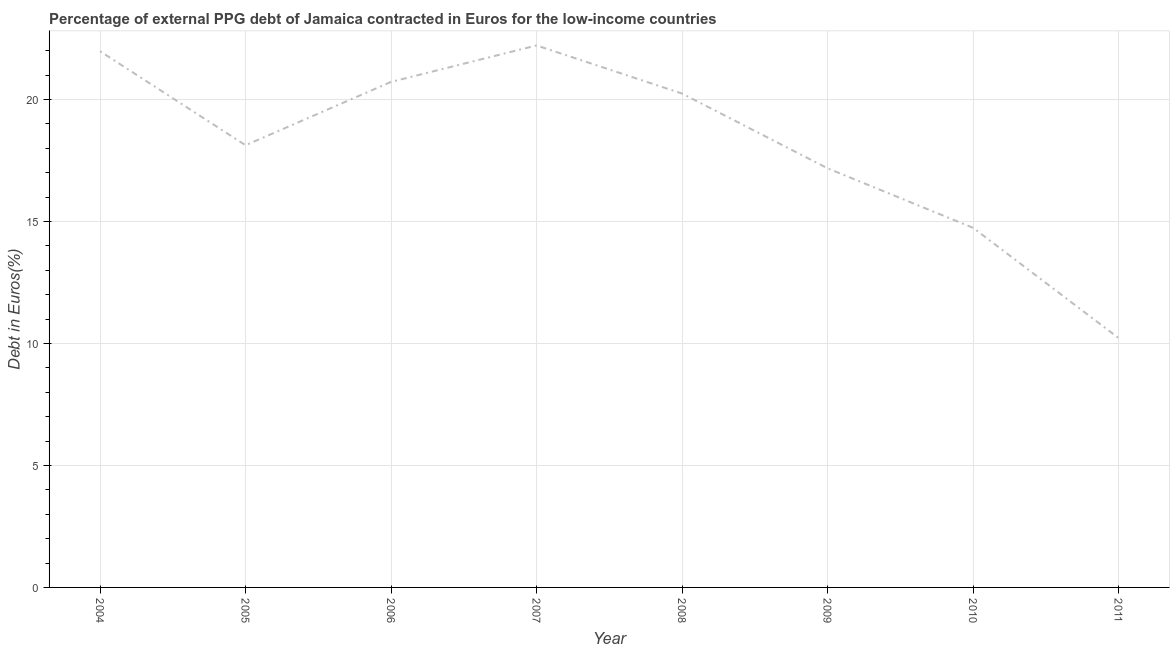What is the currency composition of ppg debt in 2005?
Ensure brevity in your answer.  18.13. Across all years, what is the maximum currency composition of ppg debt?
Offer a very short reply. 22.22. Across all years, what is the minimum currency composition of ppg debt?
Your answer should be very brief. 10.23. What is the sum of the currency composition of ppg debt?
Ensure brevity in your answer.  145.46. What is the difference between the currency composition of ppg debt in 2004 and 2005?
Offer a very short reply. 3.86. What is the average currency composition of ppg debt per year?
Offer a very short reply. 18.18. What is the median currency composition of ppg debt?
Make the answer very short. 19.19. In how many years, is the currency composition of ppg debt greater than 16 %?
Keep it short and to the point. 6. What is the ratio of the currency composition of ppg debt in 2005 to that in 2008?
Offer a terse response. 0.9. Is the currency composition of ppg debt in 2006 less than that in 2007?
Give a very brief answer. Yes. Is the difference between the currency composition of ppg debt in 2008 and 2011 greater than the difference between any two years?
Give a very brief answer. No. What is the difference between the highest and the second highest currency composition of ppg debt?
Give a very brief answer. 0.24. Is the sum of the currency composition of ppg debt in 2004 and 2007 greater than the maximum currency composition of ppg debt across all years?
Give a very brief answer. Yes. What is the difference between the highest and the lowest currency composition of ppg debt?
Make the answer very short. 11.99. Does the currency composition of ppg debt monotonically increase over the years?
Give a very brief answer. No. How many lines are there?
Make the answer very short. 1. Does the graph contain any zero values?
Give a very brief answer. No. What is the title of the graph?
Provide a succinct answer. Percentage of external PPG debt of Jamaica contracted in Euros for the low-income countries. What is the label or title of the X-axis?
Your answer should be compact. Year. What is the label or title of the Y-axis?
Offer a very short reply. Debt in Euros(%). What is the Debt in Euros(%) of 2004?
Your answer should be compact. 21.98. What is the Debt in Euros(%) of 2005?
Ensure brevity in your answer.  18.13. What is the Debt in Euros(%) in 2006?
Your answer should be very brief. 20.73. What is the Debt in Euros(%) in 2007?
Give a very brief answer. 22.22. What is the Debt in Euros(%) of 2008?
Offer a terse response. 20.25. What is the Debt in Euros(%) of 2009?
Ensure brevity in your answer.  17.18. What is the Debt in Euros(%) in 2010?
Give a very brief answer. 14.74. What is the Debt in Euros(%) in 2011?
Offer a very short reply. 10.23. What is the difference between the Debt in Euros(%) in 2004 and 2005?
Keep it short and to the point. 3.86. What is the difference between the Debt in Euros(%) in 2004 and 2006?
Your answer should be compact. 1.26. What is the difference between the Debt in Euros(%) in 2004 and 2007?
Offer a very short reply. -0.24. What is the difference between the Debt in Euros(%) in 2004 and 2008?
Your answer should be compact. 1.74. What is the difference between the Debt in Euros(%) in 2004 and 2009?
Make the answer very short. 4.8. What is the difference between the Debt in Euros(%) in 2004 and 2010?
Keep it short and to the point. 7.24. What is the difference between the Debt in Euros(%) in 2004 and 2011?
Provide a succinct answer. 11.76. What is the difference between the Debt in Euros(%) in 2005 and 2006?
Your answer should be compact. -2.6. What is the difference between the Debt in Euros(%) in 2005 and 2007?
Offer a terse response. -4.09. What is the difference between the Debt in Euros(%) in 2005 and 2008?
Your answer should be very brief. -2.12. What is the difference between the Debt in Euros(%) in 2005 and 2009?
Give a very brief answer. 0.94. What is the difference between the Debt in Euros(%) in 2005 and 2010?
Your answer should be very brief. 3.38. What is the difference between the Debt in Euros(%) in 2005 and 2011?
Your answer should be very brief. 7.9. What is the difference between the Debt in Euros(%) in 2006 and 2007?
Your response must be concise. -1.49. What is the difference between the Debt in Euros(%) in 2006 and 2008?
Keep it short and to the point. 0.48. What is the difference between the Debt in Euros(%) in 2006 and 2009?
Give a very brief answer. 3.54. What is the difference between the Debt in Euros(%) in 2006 and 2010?
Ensure brevity in your answer.  5.98. What is the difference between the Debt in Euros(%) in 2006 and 2011?
Keep it short and to the point. 10.5. What is the difference between the Debt in Euros(%) in 2007 and 2008?
Ensure brevity in your answer.  1.97. What is the difference between the Debt in Euros(%) in 2007 and 2009?
Give a very brief answer. 5.04. What is the difference between the Debt in Euros(%) in 2007 and 2010?
Your answer should be very brief. 7.48. What is the difference between the Debt in Euros(%) in 2007 and 2011?
Your answer should be compact. 11.99. What is the difference between the Debt in Euros(%) in 2008 and 2009?
Make the answer very short. 3.06. What is the difference between the Debt in Euros(%) in 2008 and 2010?
Offer a terse response. 5.5. What is the difference between the Debt in Euros(%) in 2008 and 2011?
Ensure brevity in your answer.  10.02. What is the difference between the Debt in Euros(%) in 2009 and 2010?
Your answer should be compact. 2.44. What is the difference between the Debt in Euros(%) in 2009 and 2011?
Keep it short and to the point. 6.96. What is the difference between the Debt in Euros(%) in 2010 and 2011?
Your response must be concise. 4.52. What is the ratio of the Debt in Euros(%) in 2004 to that in 2005?
Provide a succinct answer. 1.21. What is the ratio of the Debt in Euros(%) in 2004 to that in 2006?
Your answer should be very brief. 1.06. What is the ratio of the Debt in Euros(%) in 2004 to that in 2008?
Your answer should be compact. 1.09. What is the ratio of the Debt in Euros(%) in 2004 to that in 2009?
Provide a short and direct response. 1.28. What is the ratio of the Debt in Euros(%) in 2004 to that in 2010?
Provide a succinct answer. 1.49. What is the ratio of the Debt in Euros(%) in 2004 to that in 2011?
Your answer should be compact. 2.15. What is the ratio of the Debt in Euros(%) in 2005 to that in 2007?
Your answer should be compact. 0.82. What is the ratio of the Debt in Euros(%) in 2005 to that in 2008?
Keep it short and to the point. 0.9. What is the ratio of the Debt in Euros(%) in 2005 to that in 2009?
Keep it short and to the point. 1.05. What is the ratio of the Debt in Euros(%) in 2005 to that in 2010?
Make the answer very short. 1.23. What is the ratio of the Debt in Euros(%) in 2005 to that in 2011?
Offer a very short reply. 1.77. What is the ratio of the Debt in Euros(%) in 2006 to that in 2007?
Your answer should be compact. 0.93. What is the ratio of the Debt in Euros(%) in 2006 to that in 2008?
Give a very brief answer. 1.02. What is the ratio of the Debt in Euros(%) in 2006 to that in 2009?
Your response must be concise. 1.21. What is the ratio of the Debt in Euros(%) in 2006 to that in 2010?
Offer a very short reply. 1.41. What is the ratio of the Debt in Euros(%) in 2006 to that in 2011?
Your answer should be very brief. 2.03. What is the ratio of the Debt in Euros(%) in 2007 to that in 2008?
Your response must be concise. 1.1. What is the ratio of the Debt in Euros(%) in 2007 to that in 2009?
Ensure brevity in your answer.  1.29. What is the ratio of the Debt in Euros(%) in 2007 to that in 2010?
Offer a very short reply. 1.51. What is the ratio of the Debt in Euros(%) in 2007 to that in 2011?
Your answer should be compact. 2.17. What is the ratio of the Debt in Euros(%) in 2008 to that in 2009?
Your response must be concise. 1.18. What is the ratio of the Debt in Euros(%) in 2008 to that in 2010?
Provide a short and direct response. 1.37. What is the ratio of the Debt in Euros(%) in 2008 to that in 2011?
Your answer should be compact. 1.98. What is the ratio of the Debt in Euros(%) in 2009 to that in 2010?
Offer a very short reply. 1.17. What is the ratio of the Debt in Euros(%) in 2009 to that in 2011?
Your answer should be very brief. 1.68. What is the ratio of the Debt in Euros(%) in 2010 to that in 2011?
Provide a succinct answer. 1.44. 